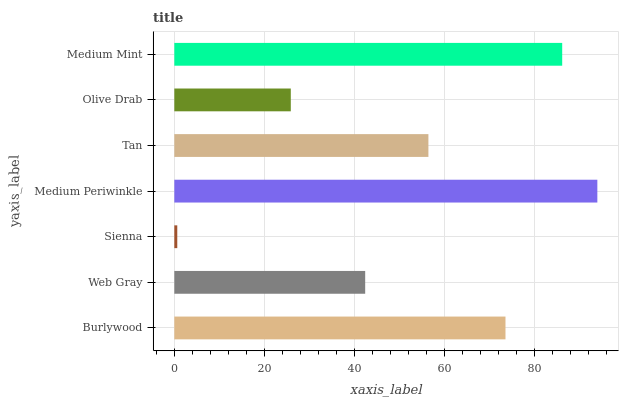Is Sienna the minimum?
Answer yes or no. Yes. Is Medium Periwinkle the maximum?
Answer yes or no. Yes. Is Web Gray the minimum?
Answer yes or no. No. Is Web Gray the maximum?
Answer yes or no. No. Is Burlywood greater than Web Gray?
Answer yes or no. Yes. Is Web Gray less than Burlywood?
Answer yes or no. Yes. Is Web Gray greater than Burlywood?
Answer yes or no. No. Is Burlywood less than Web Gray?
Answer yes or no. No. Is Tan the high median?
Answer yes or no. Yes. Is Tan the low median?
Answer yes or no. Yes. Is Burlywood the high median?
Answer yes or no. No. Is Web Gray the low median?
Answer yes or no. No. 